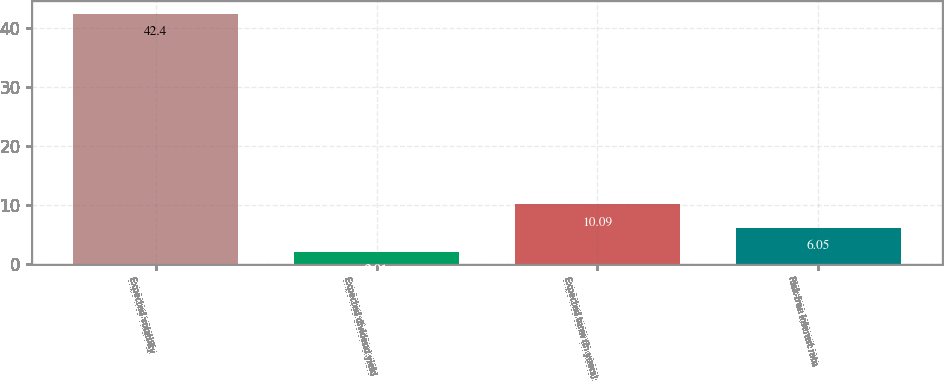<chart> <loc_0><loc_0><loc_500><loc_500><bar_chart><fcel>Expected volatility<fcel>Expected dividend yield<fcel>Expected term (in years)<fcel>Risk-free interest rate<nl><fcel>42.4<fcel>2.01<fcel>10.09<fcel>6.05<nl></chart> 